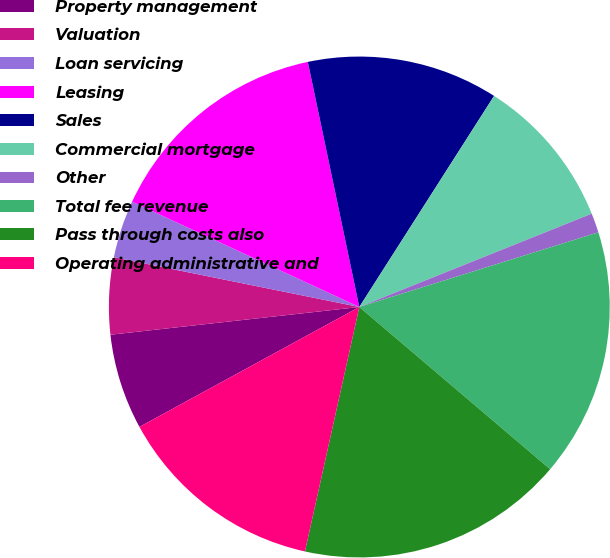Convert chart. <chart><loc_0><loc_0><loc_500><loc_500><pie_chart><fcel>Property management<fcel>Valuation<fcel>Loan servicing<fcel>Leasing<fcel>Sales<fcel>Commercial mortgage<fcel>Other<fcel>Total fee revenue<fcel>Pass through costs also<fcel>Operating administrative and<nl><fcel>6.18%<fcel>4.95%<fcel>3.72%<fcel>14.8%<fcel>12.34%<fcel>9.88%<fcel>1.26%<fcel>16.03%<fcel>17.27%<fcel>13.57%<nl></chart> 